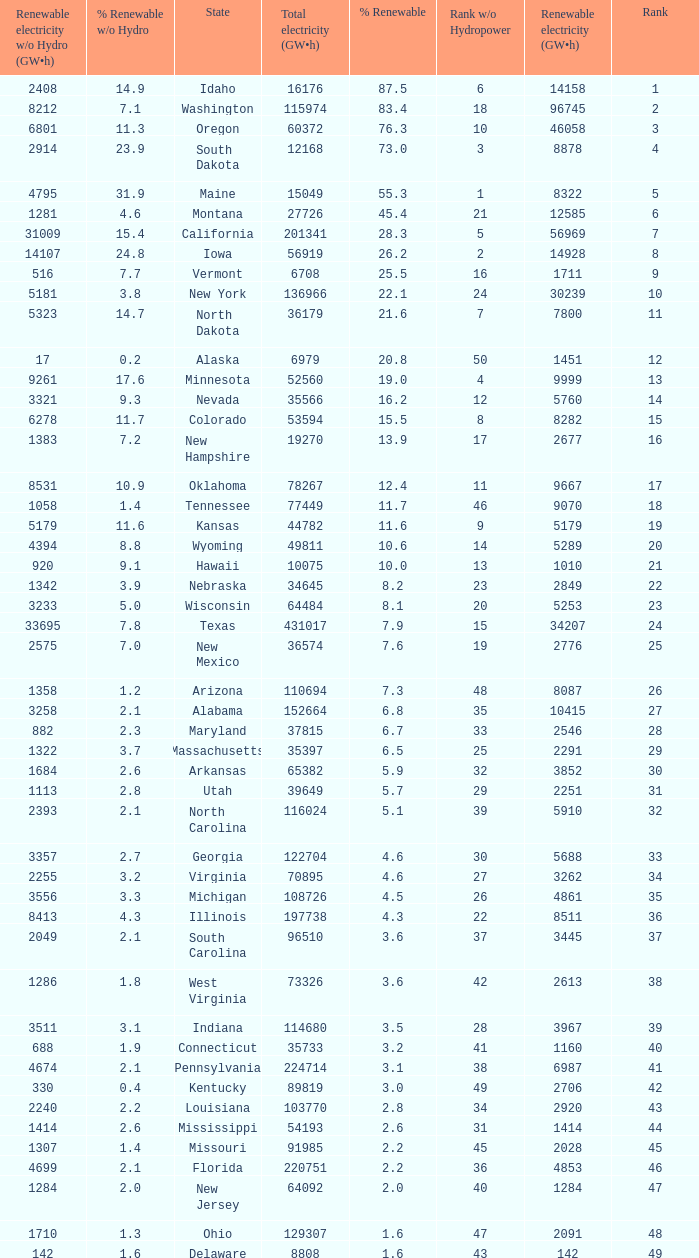What is the amount of renewable electricity without hydrogen power when the percentage of renewable energy is 83.4? 8212.0. 